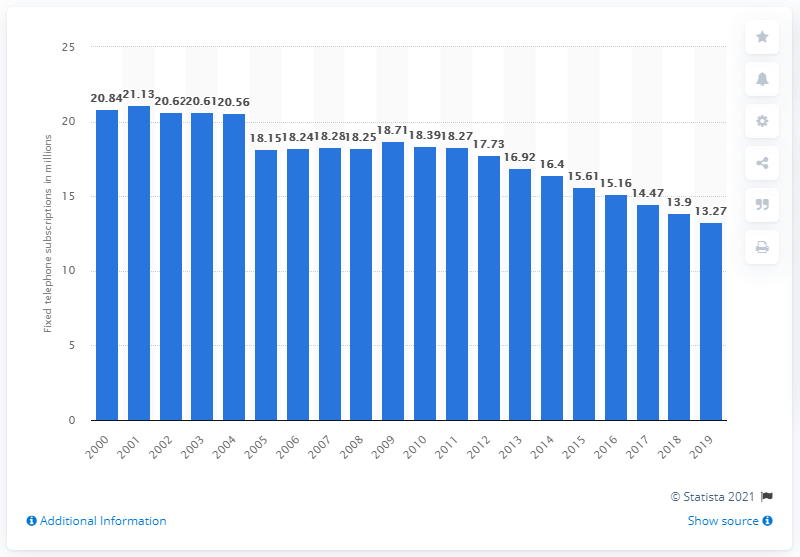Mention a couple of crucial points in this snapshot. As of the year 2019, the number of fixed telephone subscriptions registered in Canada between 2000 and 2019 was 13,270,000. 